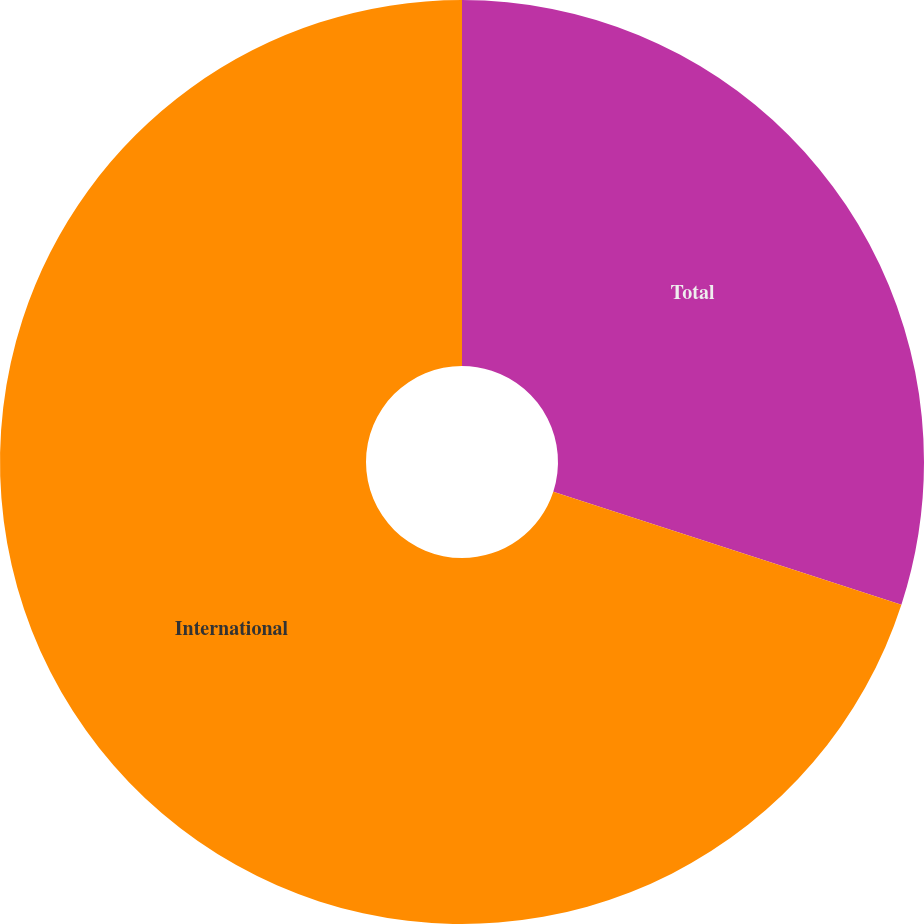Convert chart to OTSL. <chart><loc_0><loc_0><loc_500><loc_500><pie_chart><fcel>Total<fcel>International<nl><fcel>30.0%<fcel>70.0%<nl></chart> 